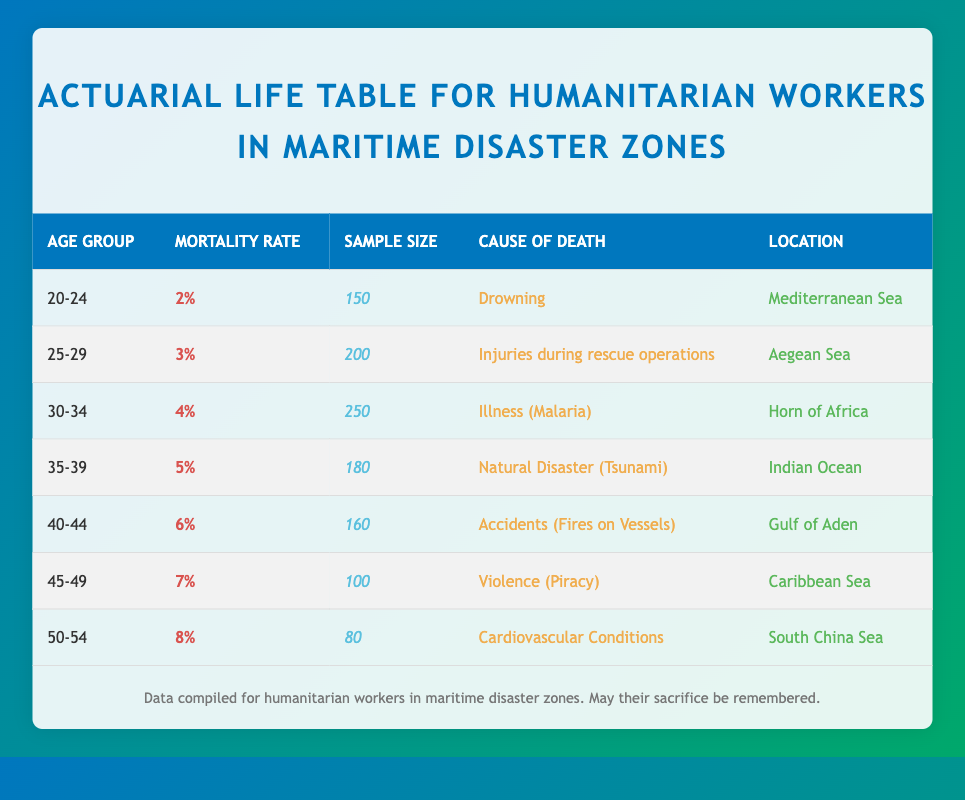What is the highest mortality rate among the age groups listed? The highest mortality rate is found in the age group 50-54, which has a mortality rate of 8%. This can be determined by scanning the "Mortality Rate" column for the maximum value.
Answer: 8% What is the cause of death for the 30-34 age group? The cause of death for the 30-34 age group is "Illness (Malaria)", as stated in the corresponding row under the "Cause of Death" column.
Answer: Illness (Malaria) Is the mortality rate for the 25-29 age group higher than that for the 20-24 age group? The mortality rate for the 25-29 age group is 3%, while the rate for the 20-24 age group is 2%. Since 3% is greater than 2%, the statement is true.
Answer: Yes What is the average mortality rate across all age groups? To find the average mortality rate, first add the mortality rates: 0.02 + 0.03 + 0.04 + 0.05 + 0.06 + 0.07 + 0.08 = 0.35. Then divide by the number of age groups, which is 7. Therefore, the average mortality rate is 0.35 / 7 = 0.05 or 5%.
Answer: 5% Which location has the highest mortality rate? The data shows that the highest mortality rate is in the 50-54 age group at 8%, located in the "South China Sea". To determine this, we identify the maximum mortality rate row and then check the corresponding location.
Answer: South China Sea How many samples were collected for the age group 40-44? The table shows that the sample size for the age group 40-44 is 160, as indicated in the "Sample Size" column for this age group.
Answer: 160 Is there a higher mortality rate for humanitarian workers in the Caribbean Sea compared to the Mediterranean Sea? The mortality rate in the Caribbean Sea for the age group 45-49 is 7%, while in the Mediterranean Sea for the age group 20-24, it is 2%. Since 7% is greater than 2%, the statement is true.
Answer: Yes What is the difference in mortality rates between age groups 35-39 and 30-34? The mortality rate for age group 35-39 is 5%, and for 30-34 it is 4%. Therefore, the difference is 5% - 4% = 1%.
Answer: 1% 